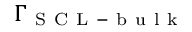Convert formula to latex. <formula><loc_0><loc_0><loc_500><loc_500>\Gamma _ { S C L - b u l k }</formula> 